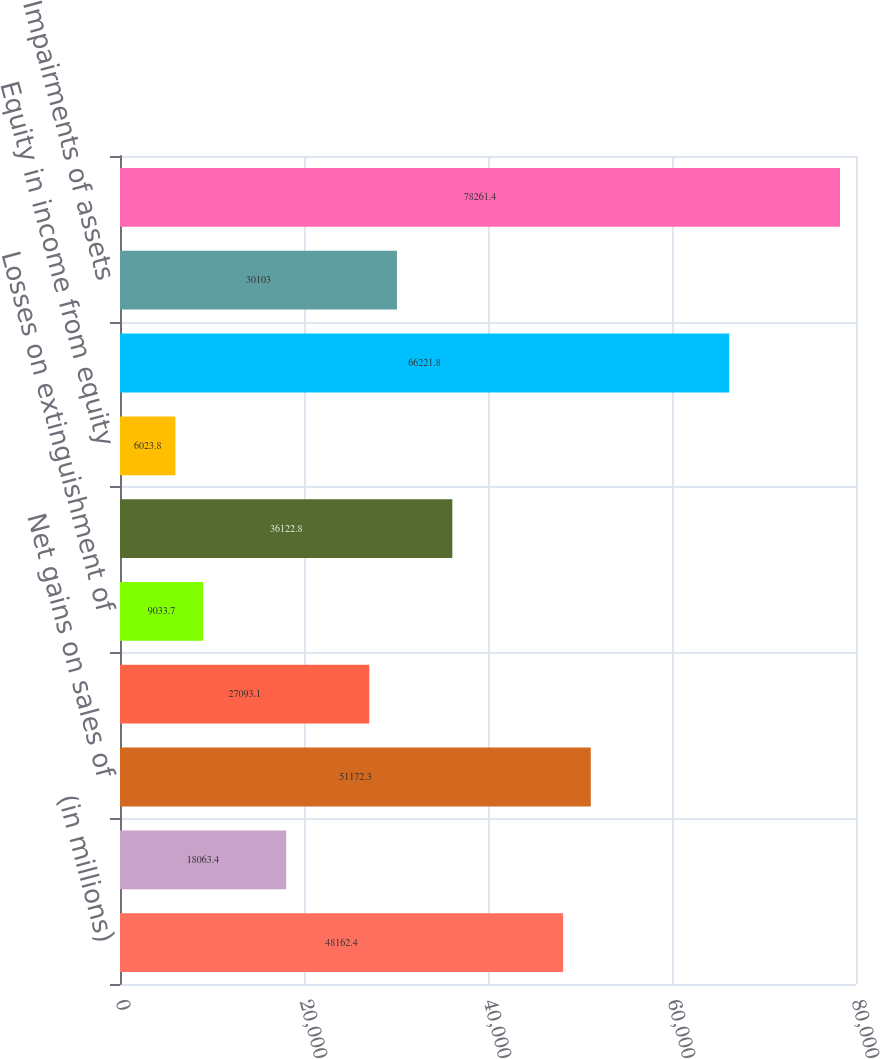<chart> <loc_0><loc_0><loc_500><loc_500><bar_chart><fcel>(in millions)<fcel>Net income (loss)<fcel>Net gains on sales of<fcel>Net (gains) losses on sales of<fcel>Losses on extinguishment of<fcel>Unrealized (gains) losses in<fcel>Equity in income from equity<fcel>Depreciation and other<fcel>Impairments of assets<fcel>Insurance reserves<nl><fcel>48162.4<fcel>18063.4<fcel>51172.3<fcel>27093.1<fcel>9033.7<fcel>36122.8<fcel>6023.8<fcel>66221.8<fcel>30103<fcel>78261.4<nl></chart> 